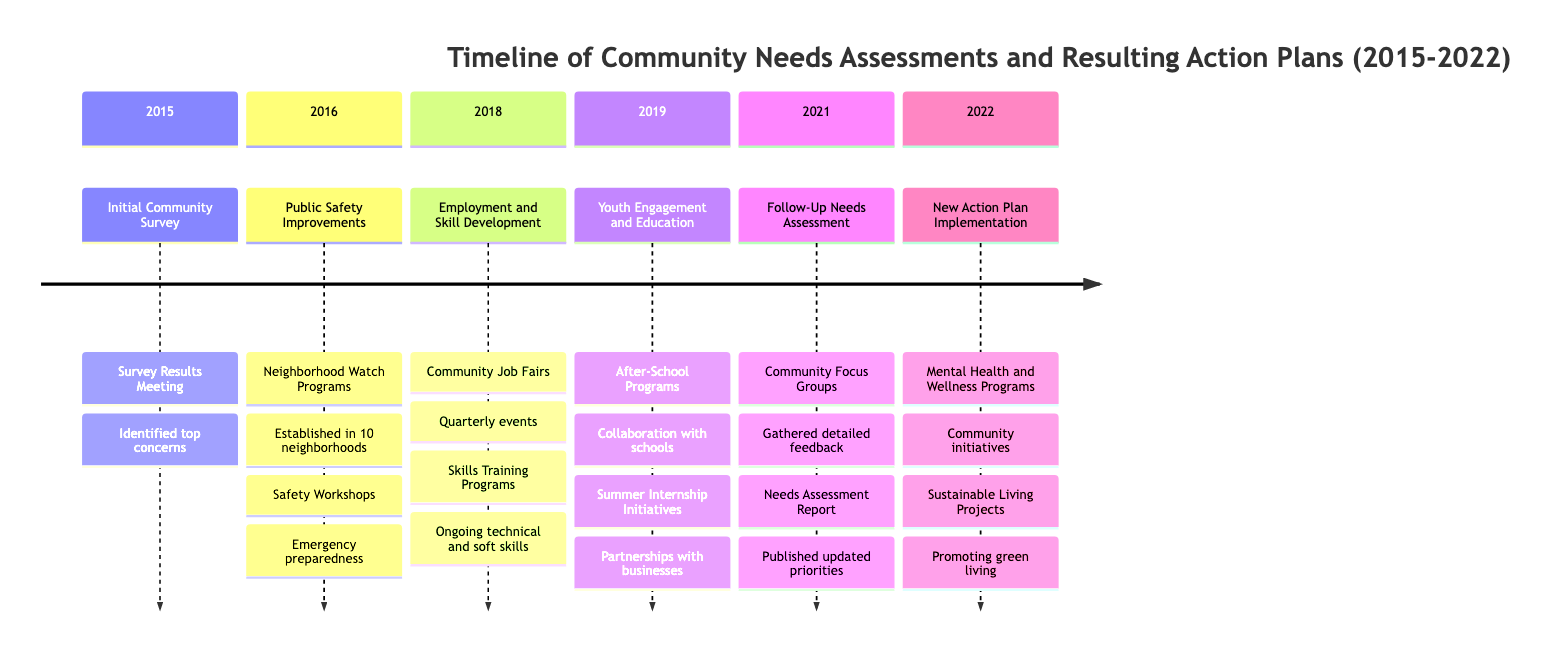What year did the Initial Community Survey take place? The initial community survey was noted as taking place in 2015, which is directly stated within the timeline.
Answer: 2015 How many neighborhoods established Neighborhood Watch Programs in 2016? The timeline states that 10 neighborhoods established Neighborhood Watch Programs, and this information is specifically mentioned in the section for 2016.
Answer: 10 What was the outcome of the Community Job Fairs in 2018? The outcome stated in the timeline is that quarterly job fairs were organized with local businesses, providing clarity on the specific result of the job fairs.
Answer: Quarterly events Which year was the Needs Assessment Report published? The timeline shows that the Needs Assessment Report was published in 2021, explicitly listed in that section.
Answer: 2021 What types of programs were rolled out in 2022 according to the timeline? The timeline indicates that Mental Health and Wellness Programs and Sustainable Living Projects were initiated in 2022, clearly outlining the actions taken that year.
Answer: Mental Health and Wellness Programs, Sustainable Living Projects Why were the Youth Engagement and Education initiatives implemented in 2019? The timeline states that these initiatives were developed based on earlier community feedback, indicating a responsive action to community needs.
Answer: Community feedback What initiative was launched to address public safety in 2016? The timeline details that Public Safety Improvements were launched, which directly addresses the need for safety based on the community survey findings.
Answer: Public Safety Improvements What was the focus of the follow-up needs assessment conducted in 2021? The follow-up needs assessment focused on gathering detailed feedback on ongoing and emerging issues, as noted in the timeline, denoting its purpose.
Answer: Ongoing and emerging issues In what month did the Mental Health and Wellness Programs start? The timeline indicates that the Mental Health and Wellness Programs were rolled out in March, providing a specific timeframe for this initiative.
Answer: March 